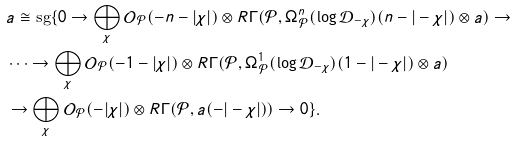<formula> <loc_0><loc_0><loc_500><loc_500>& a \cong \text {sg} \{ 0 \to \bigoplus _ { \chi } \mathcal { O } _ { \mathcal { P } } ( - n - | \chi | ) \otimes R \Gamma ( \mathcal { P } , \Omega ^ { n } _ { \mathcal { P } } ( \log \mathcal { D } _ { - \chi } ) ( n - | - \chi | ) \otimes a ) \to \\ & \dots \to \bigoplus _ { \chi } \mathcal { O } _ { \mathcal { P } } ( - 1 - | \chi | ) \otimes R \Gamma ( \mathcal { P } , \Omega ^ { 1 } _ { \mathcal { P } } ( \log \mathcal { D } _ { - \chi } ) ( 1 - | - \chi | ) \otimes a ) \\ & \to \bigoplus _ { \chi } \mathcal { O } _ { \mathcal { P } } ( - | \chi | ) \otimes R \Gamma ( \mathcal { P } , a ( - | - \chi | ) ) \to 0 \} .</formula> 